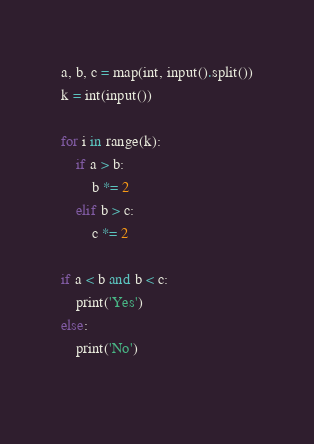Convert code to text. <code><loc_0><loc_0><loc_500><loc_500><_Python_>a, b, c = map(int, input().split())
k = int(input())

for i in range(k):
    if a > b:
        b *= 2
    elif b > c:
        c *= 2

if a < b and b < c:
    print('Yes')
else:
    print('No')
    </code> 